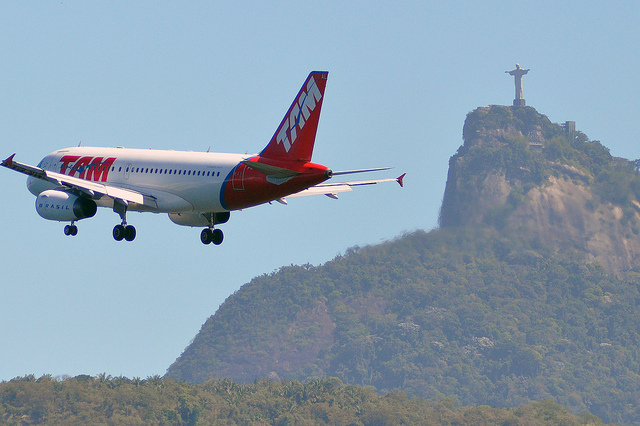What primary objects can you identify in the image? In the image, there are two primary objects: an airplane with the logo 'TAM' on it, and the Christ the Redeemer statue situated on top of a hill or mountain in the background. The statue is a notable landmark in Rio de Janeiro. 